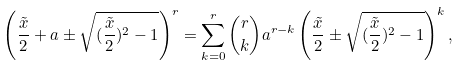<formula> <loc_0><loc_0><loc_500><loc_500>\left ( \frac { \tilde { x } } { 2 } + a \pm \sqrt { ( \frac { \tilde { x } } { 2 } ) ^ { 2 } - 1 } \right ) ^ { r } = \sum _ { k = 0 } ^ { r } \binom { r } { k } a ^ { r - k } \left ( \frac { \tilde { x } } { 2 } \pm \sqrt { ( \frac { \tilde { x } } { 2 } ) ^ { 2 } - 1 } \right ) ^ { k } ,</formula> 